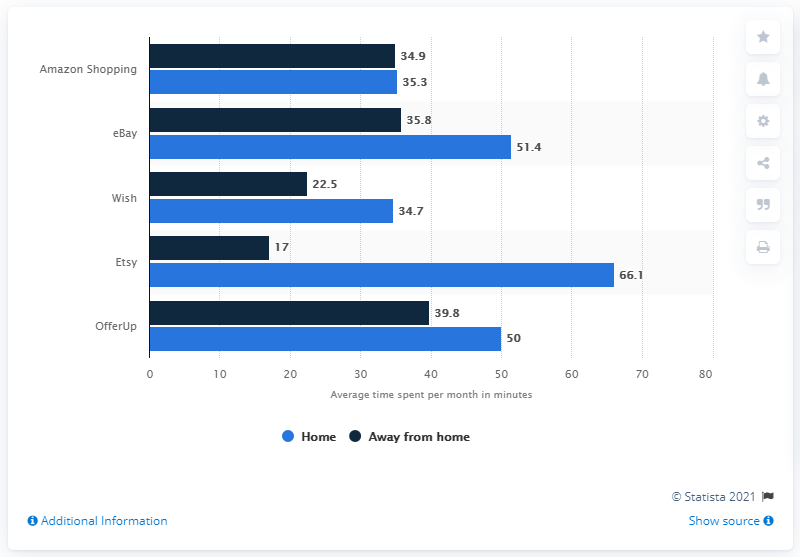Mention a couple of crucial points in this snapshot. In December 2020, Android smartphone users spent an average of 35.3 minutes per month on Amazon while at home. 